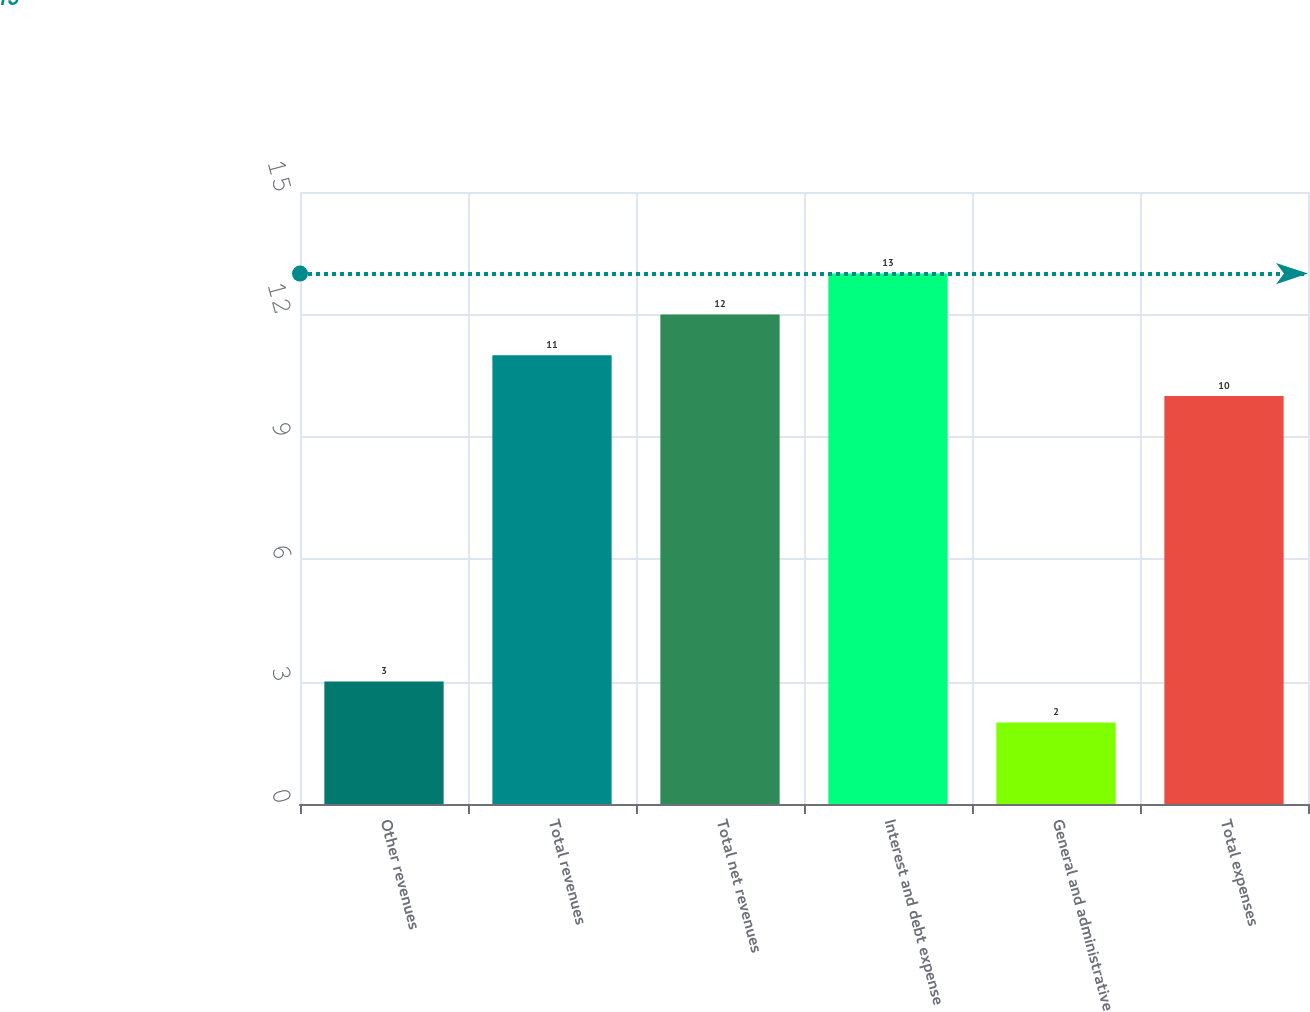Convert chart to OTSL. <chart><loc_0><loc_0><loc_500><loc_500><bar_chart><fcel>Other revenues<fcel>Total revenues<fcel>Total net revenues<fcel>Interest and debt expense<fcel>General and administrative<fcel>Total expenses<nl><fcel>3<fcel>11<fcel>12<fcel>13<fcel>2<fcel>10<nl></chart> 